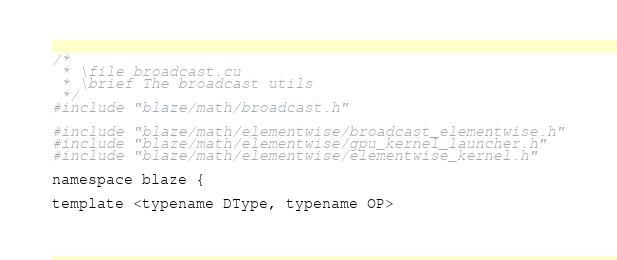Convert code to text. <code><loc_0><loc_0><loc_500><loc_500><_Cuda_>/*
 * \file broadcast.cu
 * \brief The broadcast utils 
 */
#include "blaze/math/broadcast.h"

#include "blaze/math/elementwise/broadcast_elementwise.h"
#include "blaze/math/elementwise/gpu_kernel_launcher.h"
#include "blaze/math/elementwise/elementwise_kernel.h"

namespace blaze {

template <typename DType, typename OP></code> 